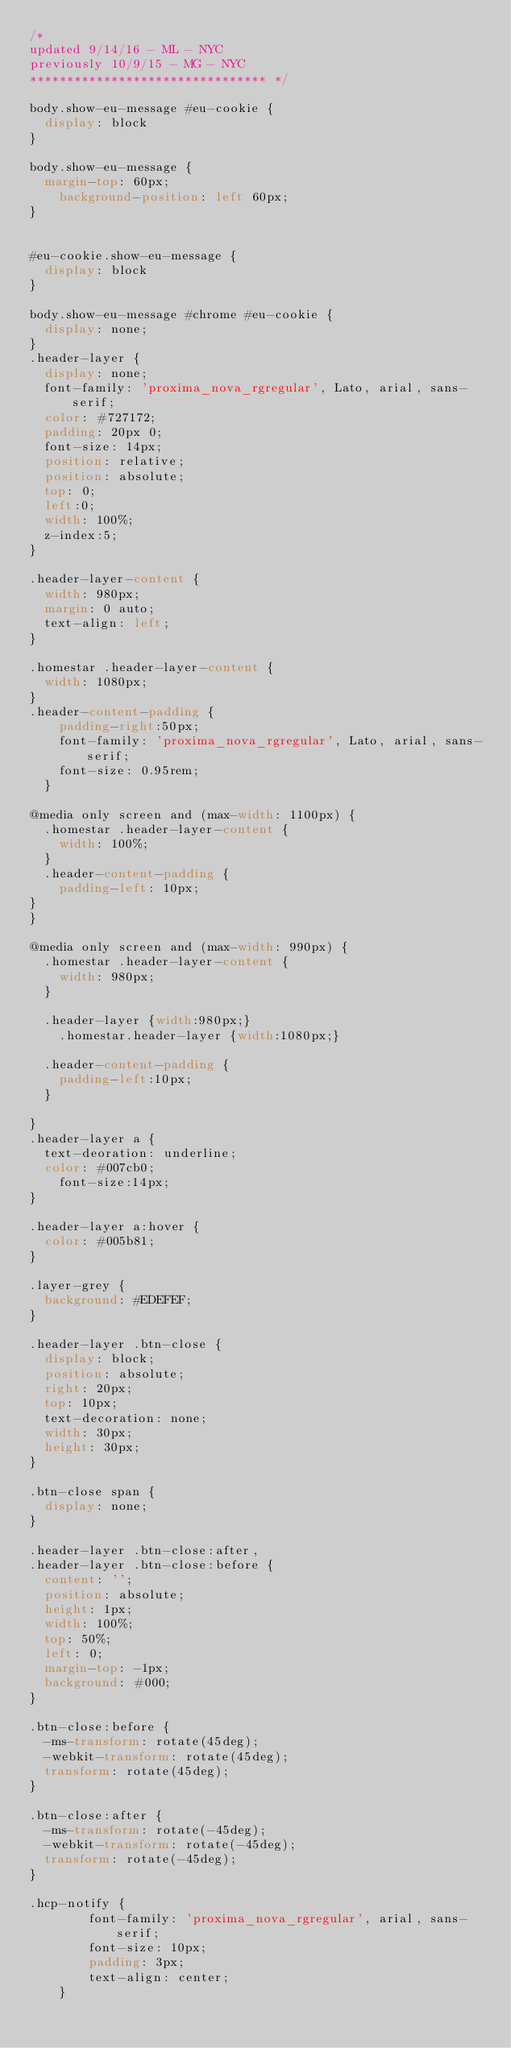<code> <loc_0><loc_0><loc_500><loc_500><_CSS_>/*
updated 9/14/16 - ML - NYC
previously 10/9/15 - MG - NYC
******************************** */

body.show-eu-message #eu-cookie {
  display: block
}

body.show-eu-message {
  margin-top: 60px;
	background-position: left 60px;
}


#eu-cookie.show-eu-message {
  display: block
}

body.show-eu-message #chrome #eu-cookie {
  display: none;
}
.header-layer {
  display: none;
  font-family: 'proxima_nova_rgregular', Lato, arial, sans-serif;
  color: #727172;
  padding: 20px 0;
  font-size: 14px;
  position: relative;
  position: absolute;
  top: 0;
  left:0;
  width: 100%;
  z-index:5;
}

.header-layer-content {
  width: 980px;
  margin: 0 auto;
  text-align: left;
}

.homestar .header-layer-content {
  width: 1080px;
}
.header-content-padding {
  	padding-right:50px;
  	font-family: 'proxima_nova_rgregular', Lato, arial, sans-serif;
  	font-size: 0.95rem;
  }

@media only screen and (max-width: 1100px) {
  .homestar .header-layer-content {
    width: 100%;
  }
  .header-content-padding {
    padding-left: 10px;
}
}

@media only screen and (max-width: 990px) {
  .homestar .header-layer-content {
    width: 980px;
  }

  .header-layer {width:980px;}
	.homestar.header-layer {width:1080px;}

  .header-content-padding {
  	padding-left:10px;
  }

}
.header-layer a {
  text-deoration: underline;
  color: #007cb0;
	font-size:14px;
}

.header-layer a:hover {
  color: #005b81;
}

.layer-grey {
  background: #EDEFEF;
}

.header-layer .btn-close {
  display: block;
  position: absolute;
  right: 20px;
  top: 10px;
  text-decoration: none;
  width: 30px;
  height: 30px;
}

.btn-close span {
  display: none;
}

.header-layer .btn-close:after,
.header-layer .btn-close:before {
  content: '';
  position: absolute;
  height: 1px;
  width: 100%;
  top: 50%;
  left: 0;
  margin-top: -1px;
  background: #000;
}

.btn-close:before {
  -ms-transform: rotate(45deg);
  -webkit-transform: rotate(45deg);
  transform: rotate(45deg);
}

.btn-close:after {
  -ms-transform: rotate(-45deg);
  -webkit-transform: rotate(-45deg);
  transform: rotate(-45deg);
}

.hcp-notify {
		font-family: 'proxima_nova_rgregular', arial, sans-serif;
		font-size: 10px;
		padding: 3px;
		text-align: center;
	}</code> 